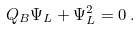Convert formula to latex. <formula><loc_0><loc_0><loc_500><loc_500>Q _ { B } \Psi _ { L } + \Psi _ { L } ^ { 2 } = 0 \, .</formula> 